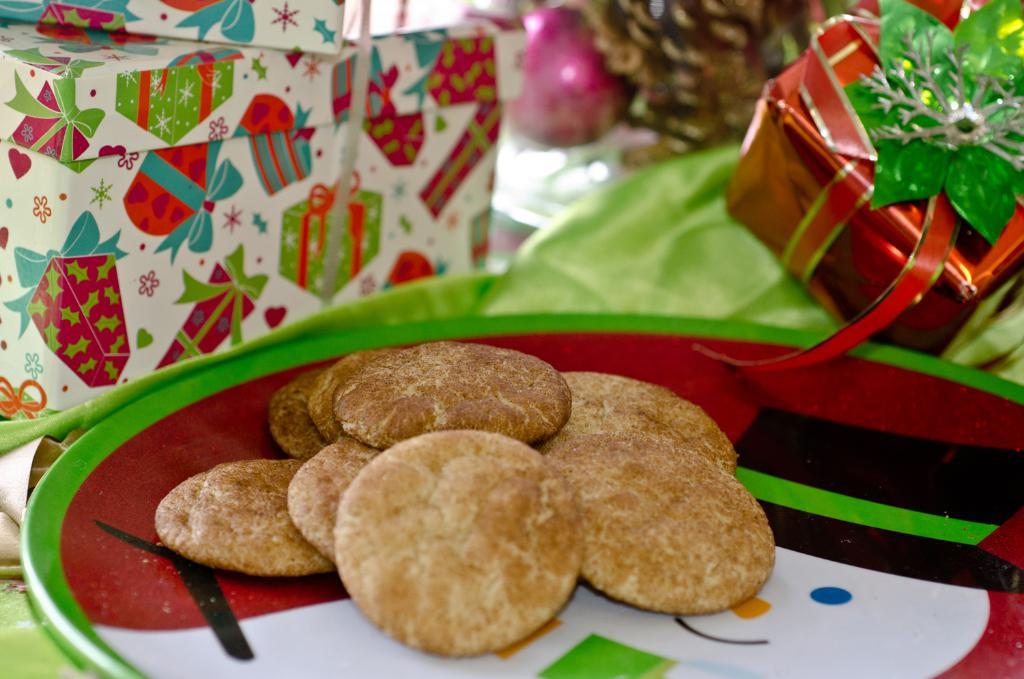What type of food is placed on the plate in the image? There are biscuits placed in a plate in the image. What colors are present on the plate? The plate has red, white, and green colors. What else can be seen in the image besides the plate of biscuits? There are gifts in the image. Where are all the items placed in the image? All the items are placed on a table. What type of flower is growing on the table in the image? There is no flower present on the table in the image. How does the person in the image crush the biscuits? There is no person present in the image, and the biscuits are not being crushed. 